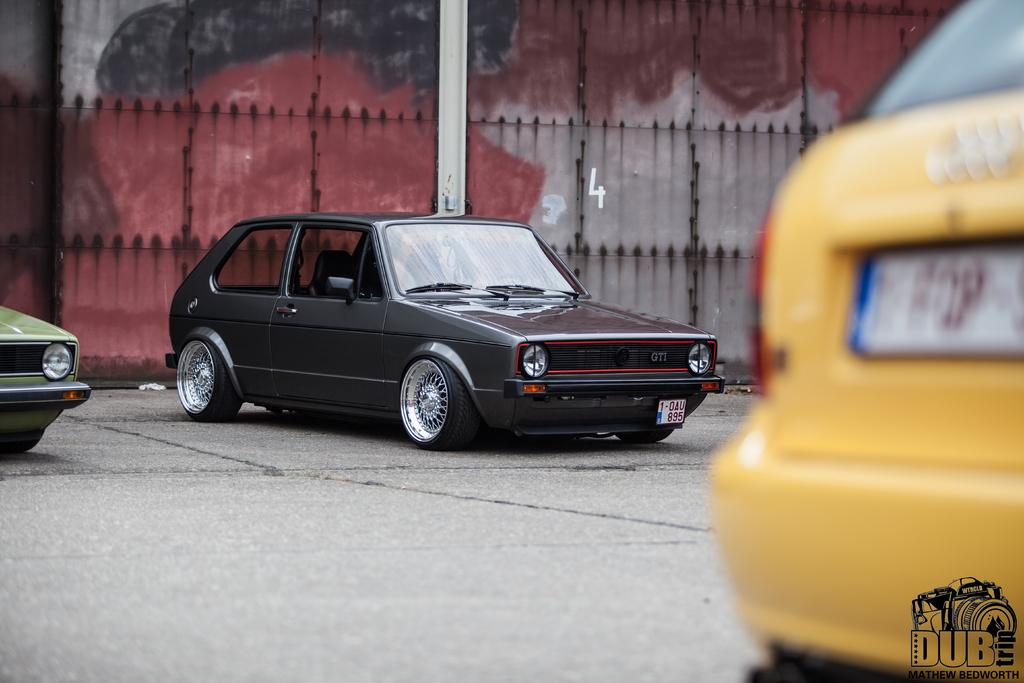<image>
Render a clear and concise summary of the photo. Two cars that are yellow and black by Dub Trip. 